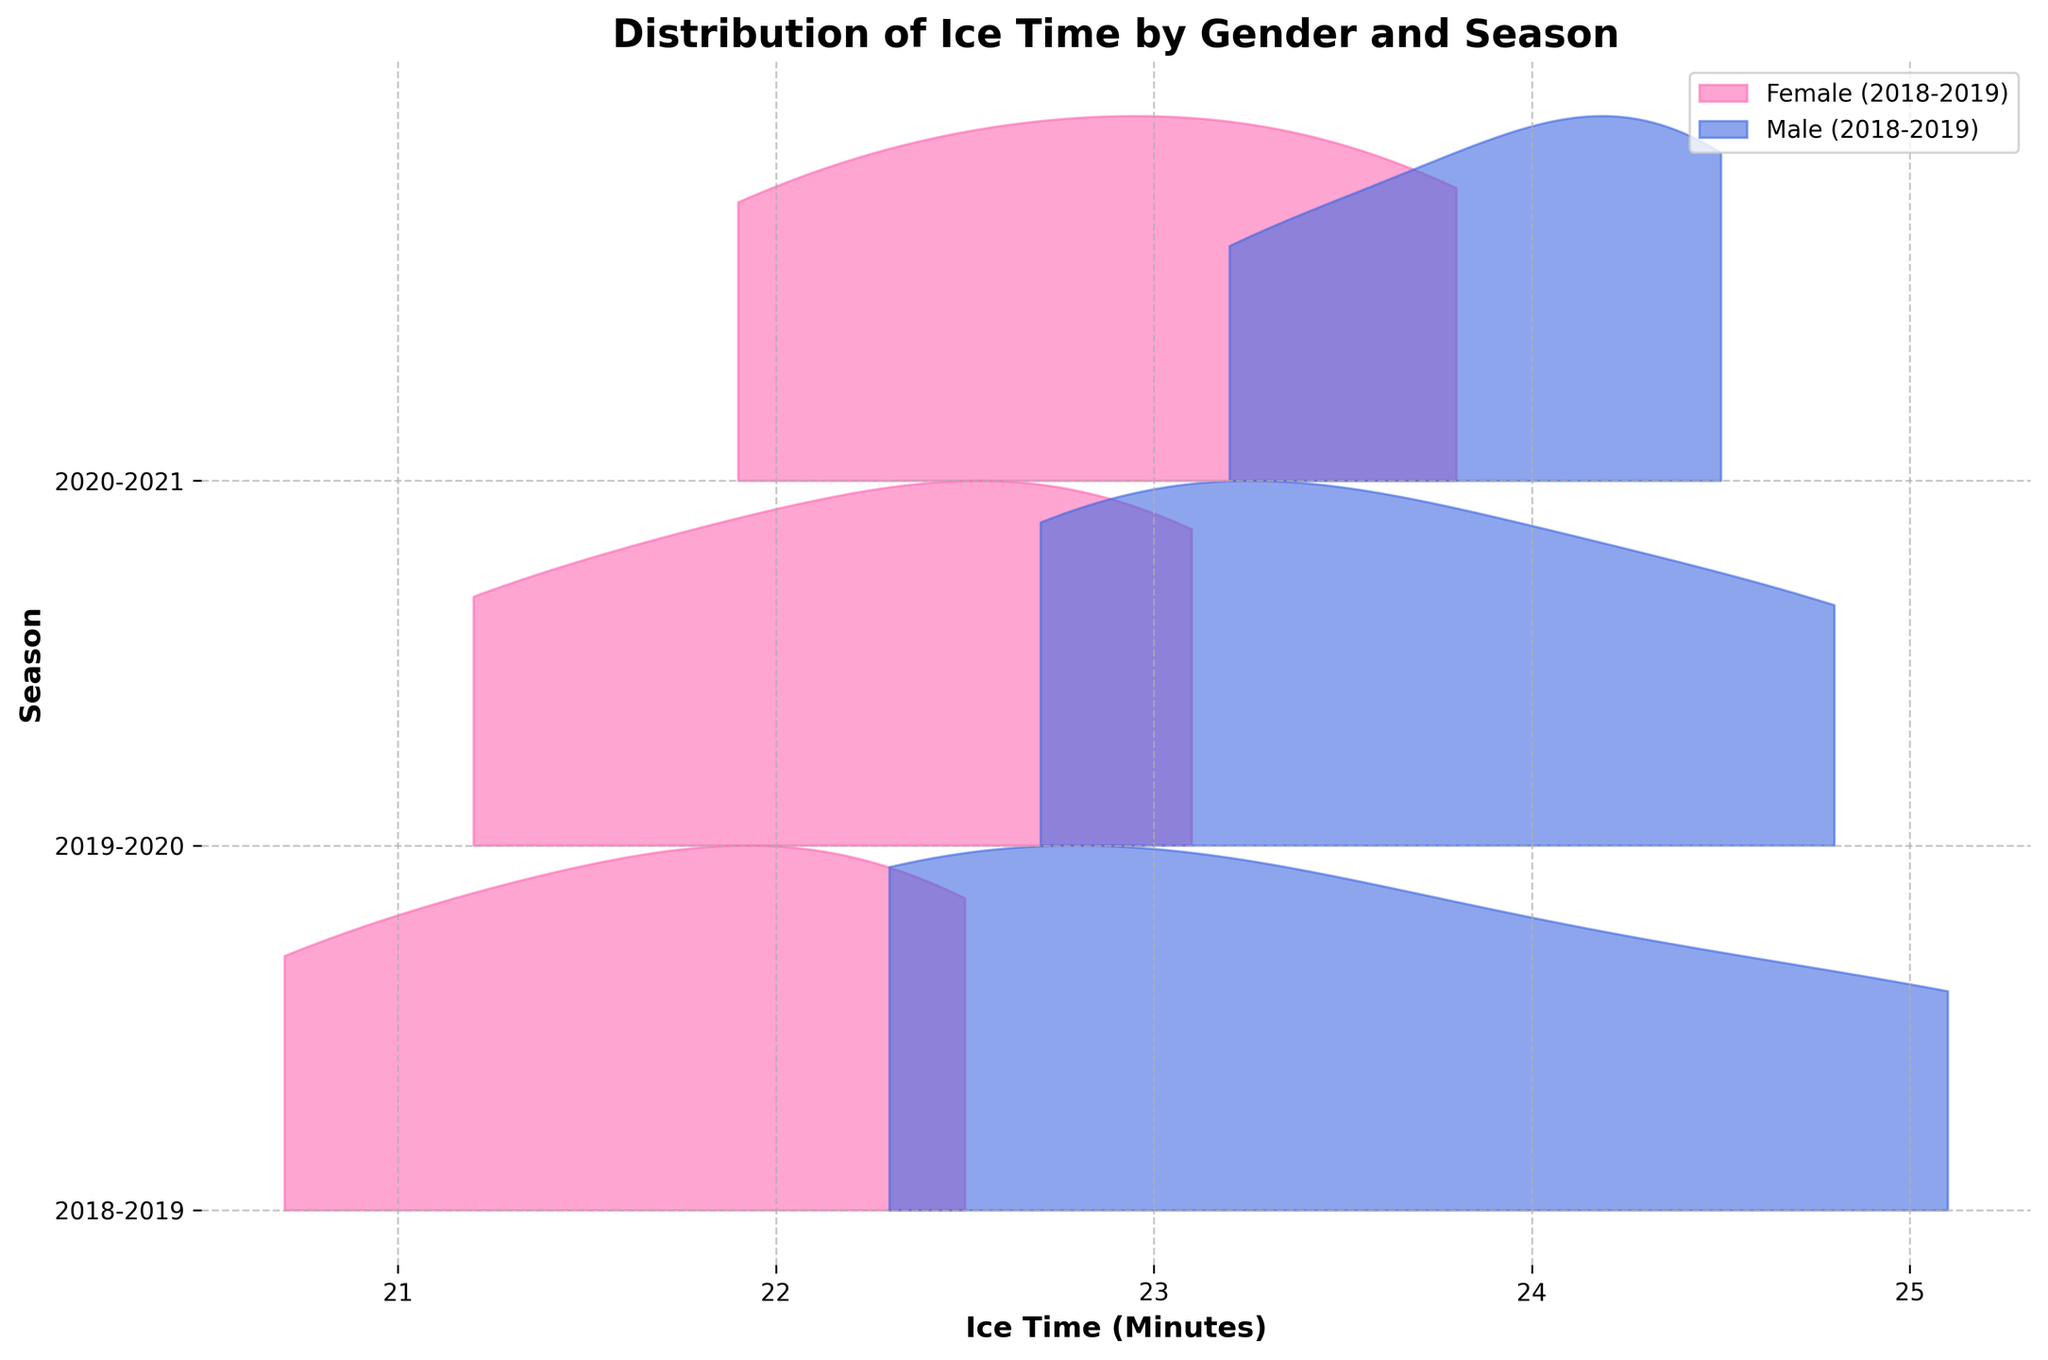Which seasons are included in the plot? The distinct seasons are typically indicated along the y-axis in the plot. By looking at the tick labels on the axis, the seasons included are 2018-2019, 2019-2020, and 2020-2021.
Answer: 2018-2019, 2019-2020, 2020-2021 What colors represent male and female players? The plot uses different colors for each gender, which can be found in the legend. The color for female players is typically pink (represented as #FF69B4), and the color for male players is blue (represented as #4169E1).
Answer: Pink for Female, Blue for Male Which gender generally has a higher distribution of ice time across the three seasons? By observing the position of the peaks of the ridges for male and female players, it can be seen that the peaks for male players are higher than those for female players in each season, indicating a higher distribution of ice time.
Answer: Male In the 2020-2021 season, which gender shows the widest distribution of ice time? Looking at the width of the distribution for each gender in the season 2020-2021, the male players' distribution extends further than the female players, showing a wider spread of ice time.
Answer: Male How does the average ice time for males in 2018-2019 compare to that in 2019-2020? By comparing the central tendency or peak of the ridgeline for males between the two seasons, we observe that the average ice time for males in 2019-2020 is slightly higher than in 2018-2019.
Answer: 2019-2020 is slightly higher Does any season show overlapping of ice time distributions between male and female players? Observing the ridgelines for each season, there is a slight overlap in the distributions of ice time for male and female players each season, indicating some players from both genders had similar ice time.
Answer: Yes What is the title of the plot? The plot's title is generally bold and placed at the top of the figure. The title of this plot is "Distribution of Ice Time by Gender and Season".
Answer: Distribution of Ice Time by Gender and Season Which season shows the highest peak for female players? By observing the peaks of the ridgeline plots for female players, the highest peak is in the 2020-2021 season compared to other seasons.
Answer: 2020-2021 In which season do female players have the least variation in their ice time? The season with the smallest spread or narrowest distribution for female players indicates the least variation. By visual inspection, this is likely to be 2018-2019.
Answer: 2018-2019 